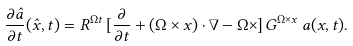Convert formula to latex. <formula><loc_0><loc_0><loc_500><loc_500>\frac { \partial \hat { a } } { \partial t } ( \hat { x } , t ) = R ^ { \Omega t } \, [ \frac { \partial } { \partial t } + ( \Omega \times x ) \cdot \nabla - \Omega \times ] \, G ^ { \Omega \times x } \, a ( x , t ) .</formula> 